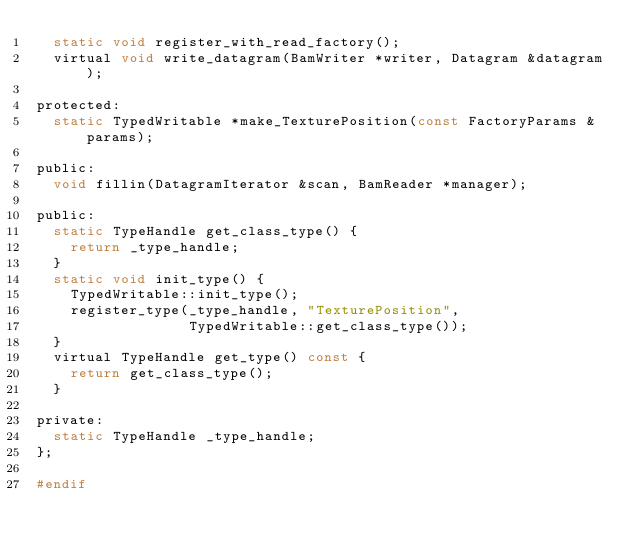Convert code to text. <code><loc_0><loc_0><loc_500><loc_500><_C_>  static void register_with_read_factory();
  virtual void write_datagram(BamWriter *writer, Datagram &datagram);

protected:
  static TypedWritable *make_TexturePosition(const FactoryParams &params);

public:
  void fillin(DatagramIterator &scan, BamReader *manager);

public:
  static TypeHandle get_class_type() {
    return _type_handle;
  }
  static void init_type() {
    TypedWritable::init_type();
    register_type(_type_handle, "TexturePosition",
                  TypedWritable::get_class_type());
  }
  virtual TypeHandle get_type() const {
    return get_class_type();
  }

private:
  static TypeHandle _type_handle;
};

#endif
</code> 